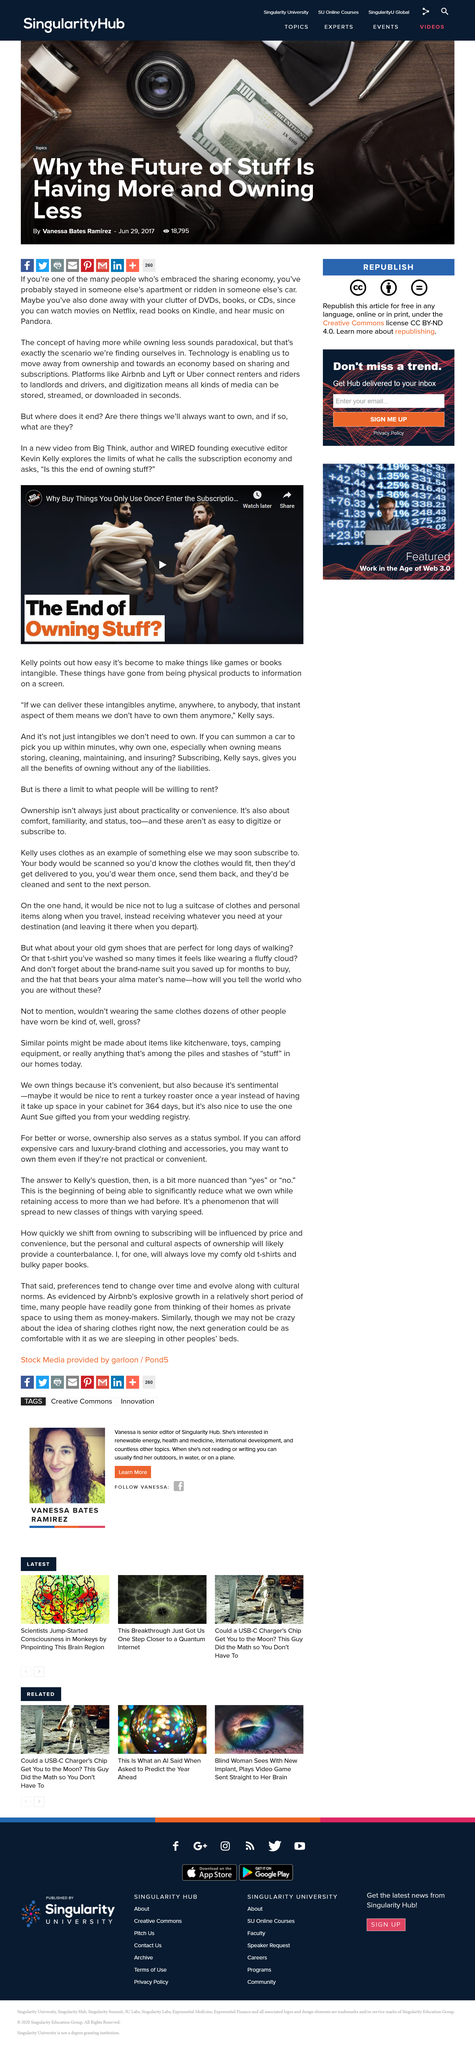Mention a couple of crucial points in this snapshot. This article has 18,795 views. This article was published on June 29, 2017, as stated in the text. I, Vanessa Bates Ramirez, am the author of this article. 